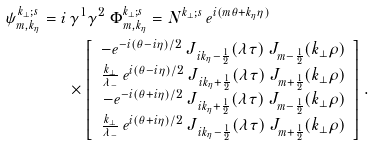<formula> <loc_0><loc_0><loc_500><loc_500>\psi ^ { k _ { \perp } ; s } _ { m , k _ { \eta } } = i & \, \gamma ^ { 1 } \gamma ^ { 2 } \ \Phi ^ { k _ { \perp } ; s } _ { m , k _ { \eta } } = N ^ { k _ { \perp } ; s } \, e ^ { i ( m \theta + k _ { \eta } \eta ) } \\ & \times \left [ \begin{array} { r } - e ^ { - i ( \theta - i \eta ) / 2 } \, J _ { \, i k _ { \eta } - \frac { 1 } { 2 } } ( \lambda \tau ) \, J _ { m - \frac { 1 } { 2 } } ( k _ { \perp } \rho ) \\ \frac { k _ { \perp } } { \lambda _ { - } } \, e ^ { i ( \theta - i \eta ) / 2 } \, J _ { \, i k _ { \eta } + \frac { 1 } { 2 } } ( \lambda \tau ) \, J _ { m + \frac { 1 } { 2 } } ( k _ { \perp } \rho ) \\ - e ^ { - i ( \theta + i \eta ) / 2 } \, J _ { \, i k _ { \eta } + \frac { 1 } { 2 } } ( \lambda \tau ) \, J _ { m - \frac { 1 } { 2 } } ( k _ { \perp } \rho ) \\ \frac { k _ { \perp } } { \lambda _ { - } } \, e ^ { i ( \theta + i \eta ) / 2 } \, J _ { \, i k _ { \eta } - \frac { 1 } { 2 } } ( \lambda \tau ) \, J _ { m + \frac { 1 } { 2 } } ( k _ { \perp } \rho ) \end{array} \right ] .</formula> 